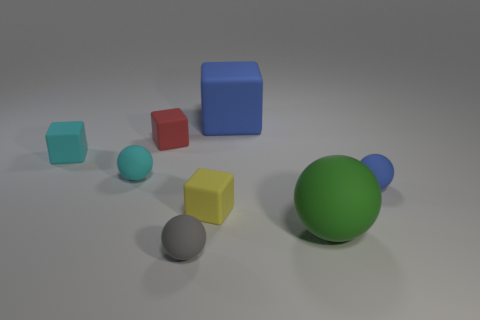Add 2 large cubes. How many objects exist? 10 Add 1 green rubber spheres. How many green rubber spheres are left? 2 Add 6 small cyan matte spheres. How many small cyan matte spheres exist? 7 Subtract 0 purple balls. How many objects are left? 8 Subtract all red blocks. Subtract all blue rubber spheres. How many objects are left? 6 